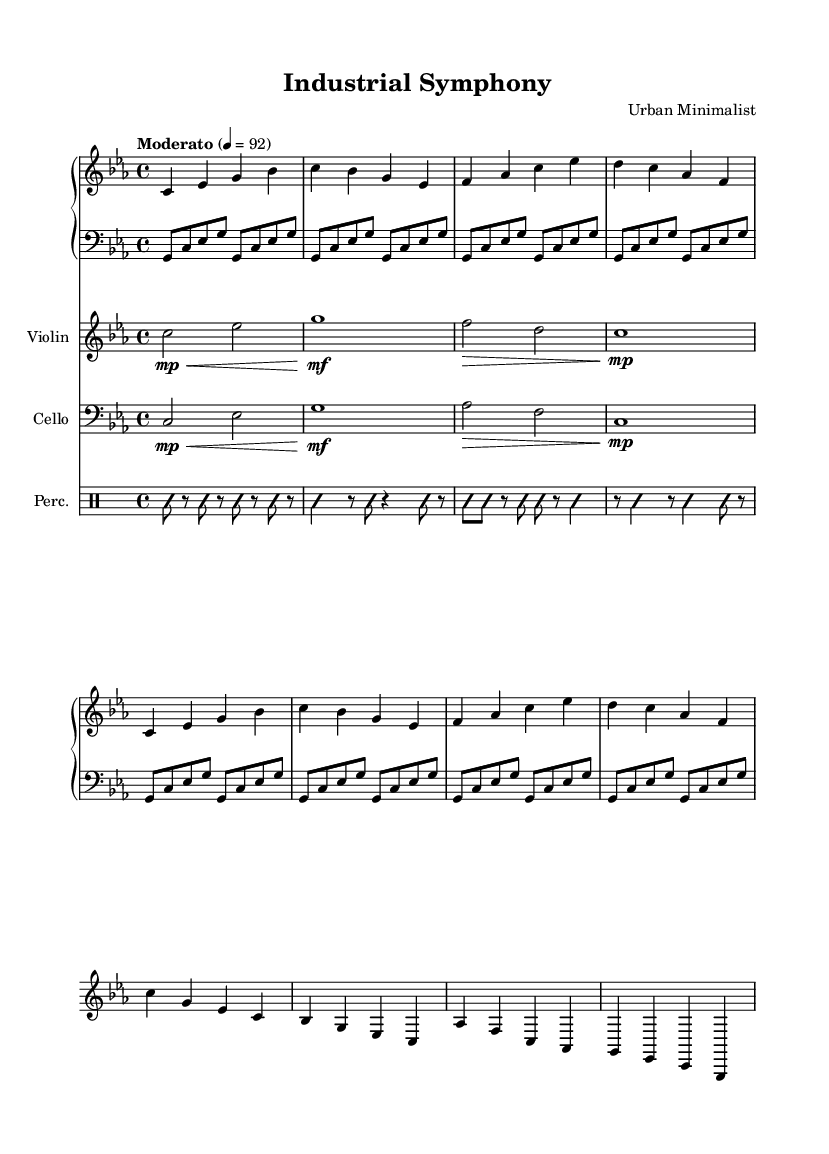What is the key signature of this music? The key signature is indicated by the accidental notes at the beginning of the staff. In this score, it shows three flats. Therefore, the key signature corresponds to C minor.
Answer: C minor What is the time signature of this music? The time signature is located at the beginning of the score, which indicates how many beats are in each measure. Here, 4/4 is shown, meaning there are four beats per measure.
Answer: 4/4 What is the tempo marking for this piece? The tempo marking is indicated near the beginning of the score. It states "Moderato" and the metronome marking of 92 beats per minute specifies the speed at which the music should be played.
Answer: Moderato, 92 How many measures are in the main theme section? To find the number of measures in the main theme, I can count the bar lines in that specific section. The main theme has 4 measures.
Answer: 4 Which instruments are included in this composition? The instruments can be identified in the score section that lists the different staves. It explicitly shows Piano, Violin, Cello, and Percussion.
Answer: Piano, Violin, Cello, Percussion What is the dynamics indication for the violin in measure 1? The dynamics for the violin part in measure 1 is notated with "mp" (mezzo-piano) and also includes a hairpin indicating it should gradually get louder, starting soft.
Answer: mp 